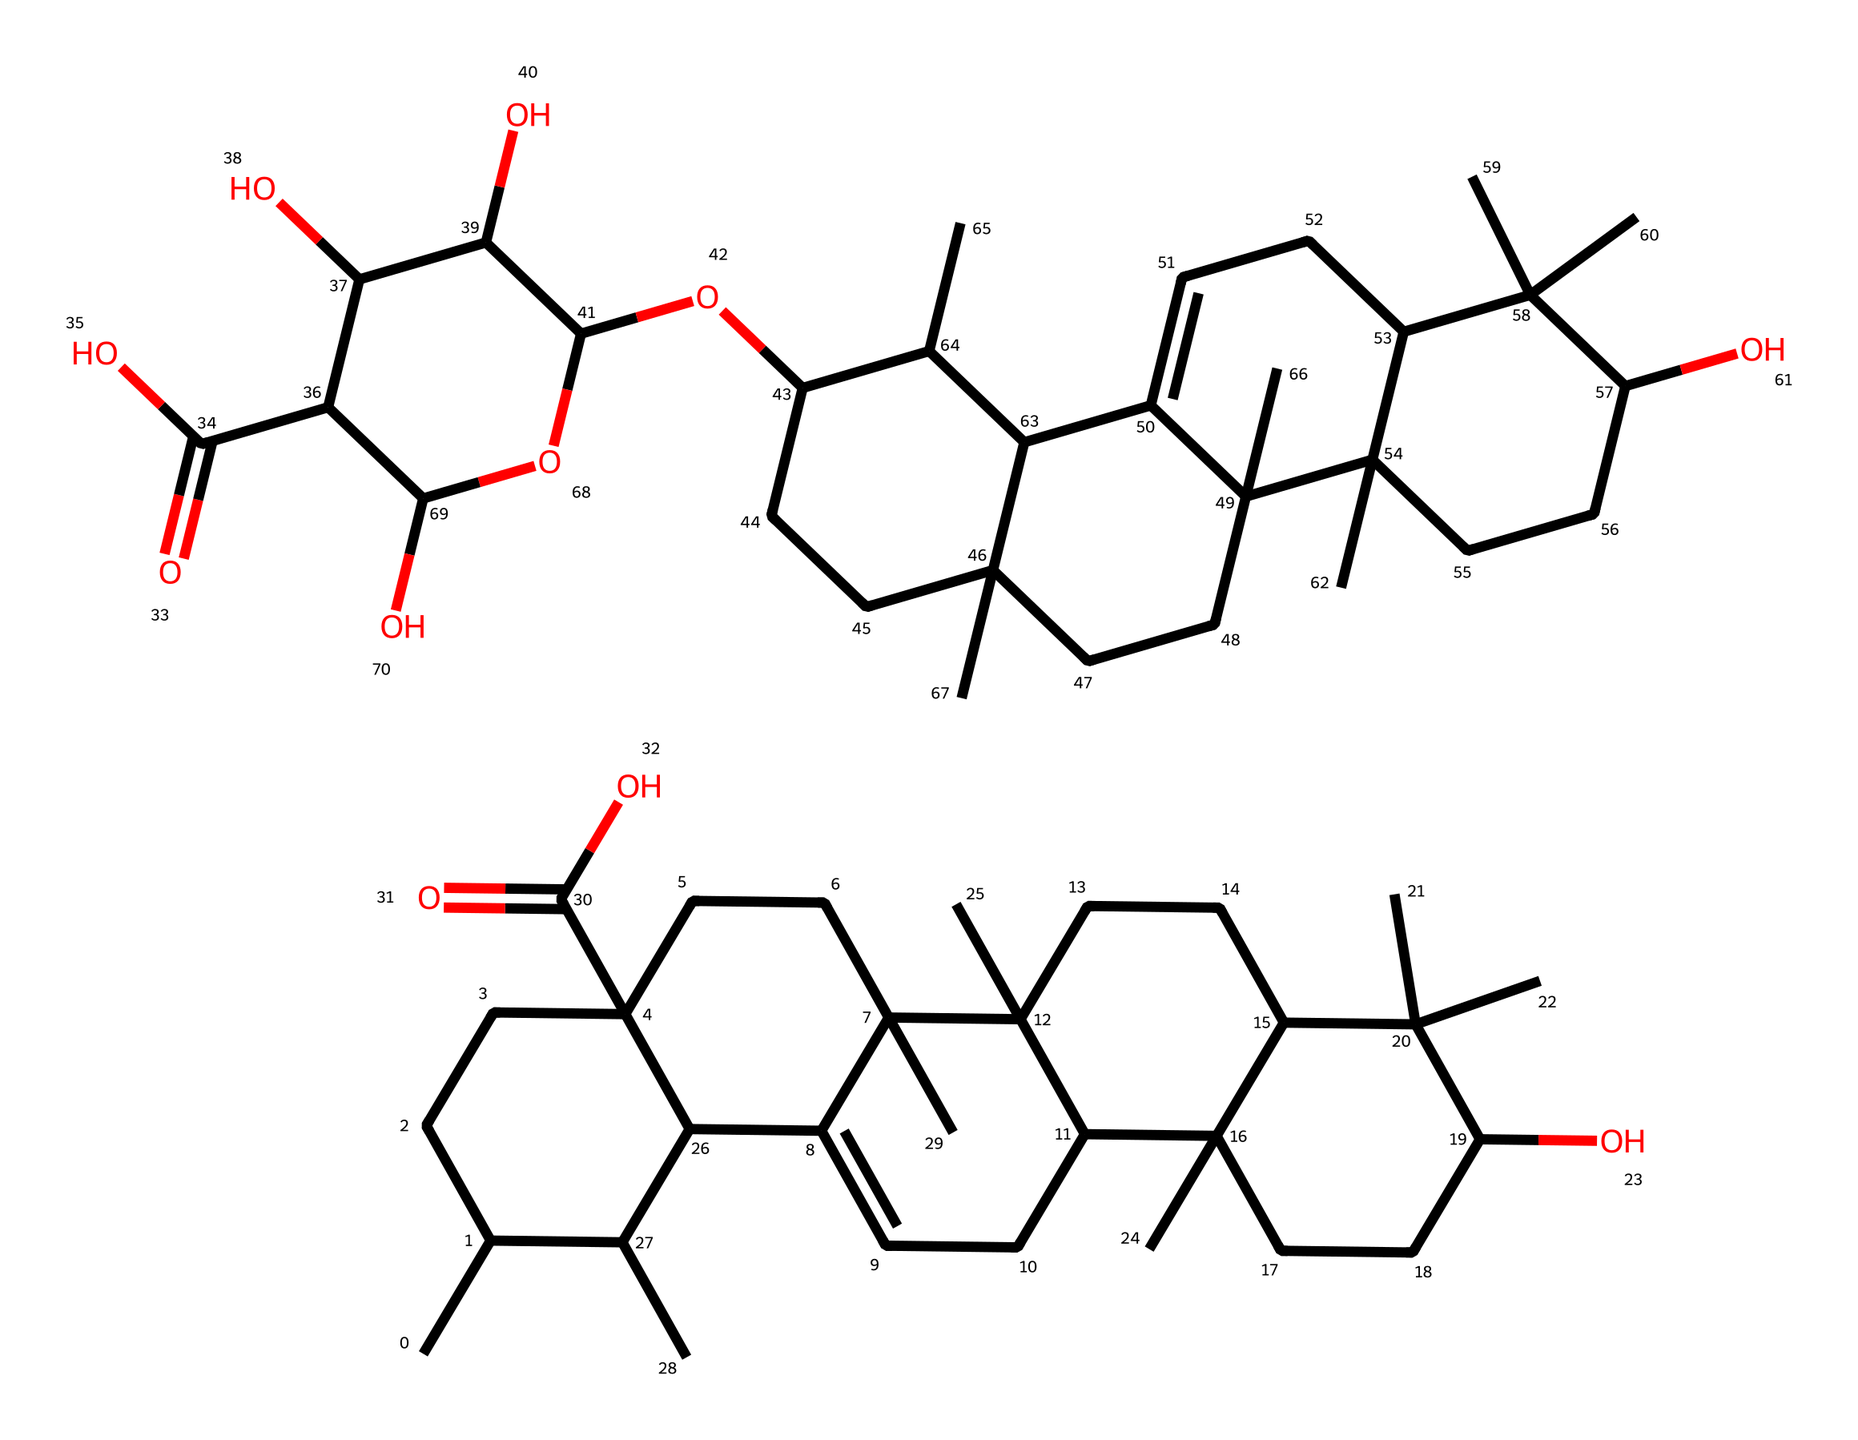How many carbon atoms are in the saponin molecule? Count the number of carbon (C) atoms present in the SMILES representation, noting that each "C" stands for a carbon atom. The total adds up to 30 carbon atoms.
Answer: 30 What is the main functional group present in the saponin structure? Analyze the molecular structure for notable groups. The presence of "C(=O)" indicates a carboxylic acid functional group, which is a prominent feature in this structure.
Answer: carboxylic acid What is the total number of oxygen atoms in the molecule? Identify and count the number of oxygen (O) atoms in the SMILES notation, where each "O" signifies an oxygen atom. The count reveals 6 oxygen atoms in total.
Answer: 6 How does the presence of multiple hydroxyl (-OH) groups influence the surfactant properties of saponin? Hydroxyl groups increase hydrophilicity, allowing saponin to interact more effectively with water and oils, enhancing its surfactant capabilities.
Answer: enhances solubility What type of surfactant is quinoa saponin classified as? Evaluate the structure based on its amphiphilic nature, as it has both hydrophilic and hydrophobic parts, indicating it is a non-ionic surfactant.
Answer: non-ionic How might the branching in the carbon chain affect the emulsifying ability of saponin? The branching can create a more compact structure, which helps stabilize emulsions by preventing coalescence of oil droplets, thereby improving emulsifying properties.
Answer: stabilizes emulsions What is the significance of the double bonds present in the carbon chain of saponin? Double bonds introduce unsaturation, affecting the molecule's flexibility and interactions with other substances, which may influence its performance as a surfactant.
Answer: affects flexibility 